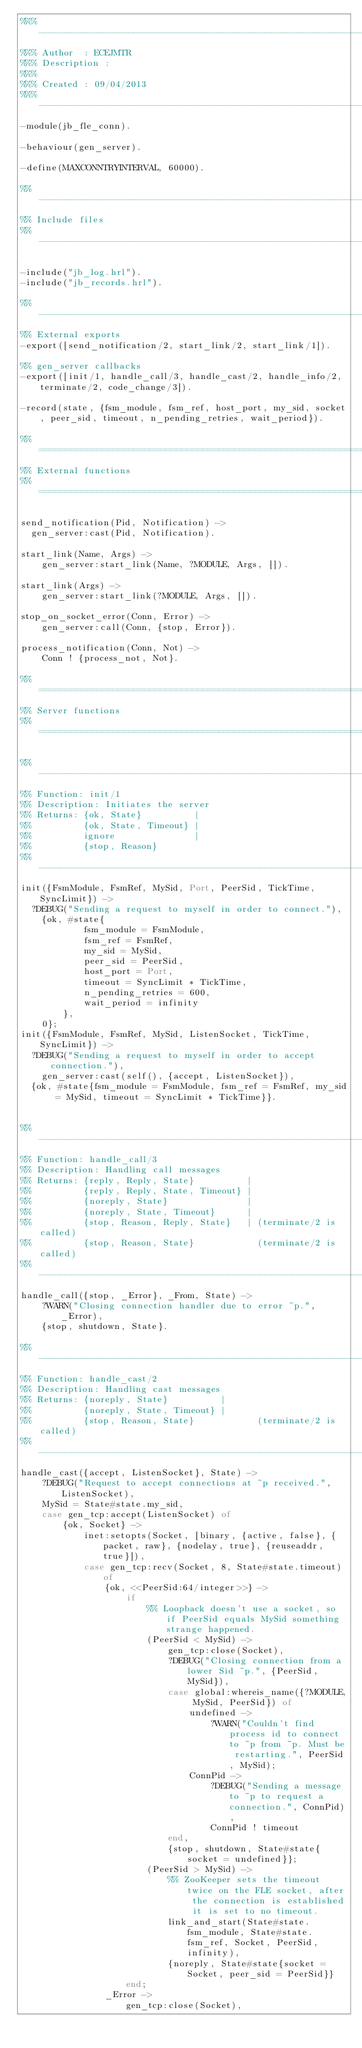<code> <loc_0><loc_0><loc_500><loc_500><_Erlang_>%%% -------------------------------------------------------------------
%%% Author  : ECEJMTR
%%% Description :
%%%
%%% Created : 09/04/2013
%%% -------------------------------------------------------------------
-module(jb_fle_conn).

-behaviour(gen_server).

-define(MAXCONNTRYINTERVAL, 60000).

%% --------------------------------------------------------------------
%% Include files
%% --------------------------------------------------------------------

-include("jb_log.hrl").
-include("jb_records.hrl").

%% --------------------------------------------------------------------
%% External exports
-export([send_notification/2, start_link/2, start_link/1]).

%% gen_server callbacks
-export([init/1, handle_call/3, handle_cast/2, handle_info/2, terminate/2, code_change/3]).

-record(state, {fsm_module, fsm_ref, host_port, my_sid, socket, peer_sid, timeout, n_pending_retries, wait_period}).

%% ====================================================================
%% External functions
%% ====================================================================

send_notification(Pid, Notification) ->
	gen_server:cast(Pid, Notification).

start_link(Name, Args) ->
    gen_server:start_link(Name, ?MODULE, Args, []).

start_link(Args) ->
    gen_server:start_link(?MODULE, Args, []).

stop_on_socket_error(Conn, Error) ->
    gen_server:call(Conn, {stop, Error}).

process_notification(Conn, Not) ->
    Conn ! {process_not, Not}.

%% ====================================================================
%% Server functions
%% ====================================================================

%% --------------------------------------------------------------------
%% Function: init/1
%% Description: Initiates the server
%% Returns: {ok, State}          |
%%          {ok, State, Timeout} |
%%          ignore               |
%%          {stop, Reason}
%% --------------------------------------------------------------------
init({FsmModule, FsmRef, MySid, Port, PeerSid, TickTime, SyncLimit}) ->
	?DEBUG("Sending a request to myself in order to connect."),
    {ok, #state{
            fsm_module = FsmModule, 
            fsm_ref = FsmRef, 
            my_sid = MySid, 
            peer_sid = PeerSid, 
            host_port = Port, 
            timeout = SyncLimit * TickTime,
            n_pending_retries = 600,
            wait_period = infinity
        },
    0};
init({FsmModule, FsmRef, MySid, ListenSocket, TickTime, SyncLimit}) ->
	?DEBUG("Sending a request to myself in order to accept connection."),
    gen_server:cast(self(), {accept, ListenSocket}),
	{ok, #state{fsm_module = FsmModule, fsm_ref = FsmRef, my_sid = MySid, timeout = SyncLimit * TickTime}}.


%% --------------------------------------------------------------------
%% Function: handle_call/3
%% Description: Handling call messages
%% Returns: {reply, Reply, State}          |
%%          {reply, Reply, State, Timeout} |
%%          {noreply, State}               |
%%          {noreply, State, Timeout}      |
%%          {stop, Reason, Reply, State}   | (terminate/2 is called)
%%          {stop, Reason, State}            (terminate/2 is called)
%% --------------------------------------------------------------------
handle_call({stop, _Error}, _From, State) ->
    ?WARN("Closing connection handler due to error ~p.", _Error),
    {stop, shutdown, State}.

%% --------------------------------------------------------------------
%% Function: handle_cast/2
%% Description: Handling cast messages
%% Returns: {noreply, State}          |
%%          {noreply, State, Timeout} |
%%          {stop, Reason, State}            (terminate/2 is called)
%% --------------------------------------------------------------------
handle_cast({accept, ListenSocket}, State) ->
    ?DEBUG("Request to accept connections at ~p received.", ListenSocket),
    MySid = State#state.my_sid,
    case gen_tcp:accept(ListenSocket) of
        {ok, Socket} ->
            inet:setopts(Socket, [binary, {active, false}, {packet, raw}, {nodelay, true}, {reuseaddr, true}]),
            case gen_tcp:recv(Socket, 8, State#state.timeout) of
                {ok, <<PeerSid:64/integer>>} ->
                    if
                        %% Loopback doesn't use a socket, so if PeerSid equals MySid something strange happened.
                        (PeerSid < MySid) ->
                            gen_tcp:close(Socket),
                            ?DEBUG("Closing connection from a lower Sid ~p.", {PeerSid, MySid}),
                            case global:whereis_name({?MODULE, MySid, PeerSid}) of
                                undefined ->
                                    ?WARN("Couldn't find process id to connect to ~p from ~p. Must be restarting.", PeerSid, MySid);
                                ConnPid ->
                                    ?DEBUG("Sending a message to ~p to request a connection.", ConnPid),
                                    ConnPid ! timeout
                            end,
                            {stop, shutdown, State#state{socket = undefined}};
                        (PeerSid > MySid) ->
                            %% ZooKeeper sets the timeout twice on the FLE socket, after the connection is established it is set to no timeout.
                            link_and_start(State#state.fsm_module, State#state.fsm_ref, Socket, PeerSid, infinity),
                            {noreply, State#state{socket = Socket, peer_sid = PeerSid}}
                    end;
                _Error ->
                    gen_tcp:close(Socket),</code> 